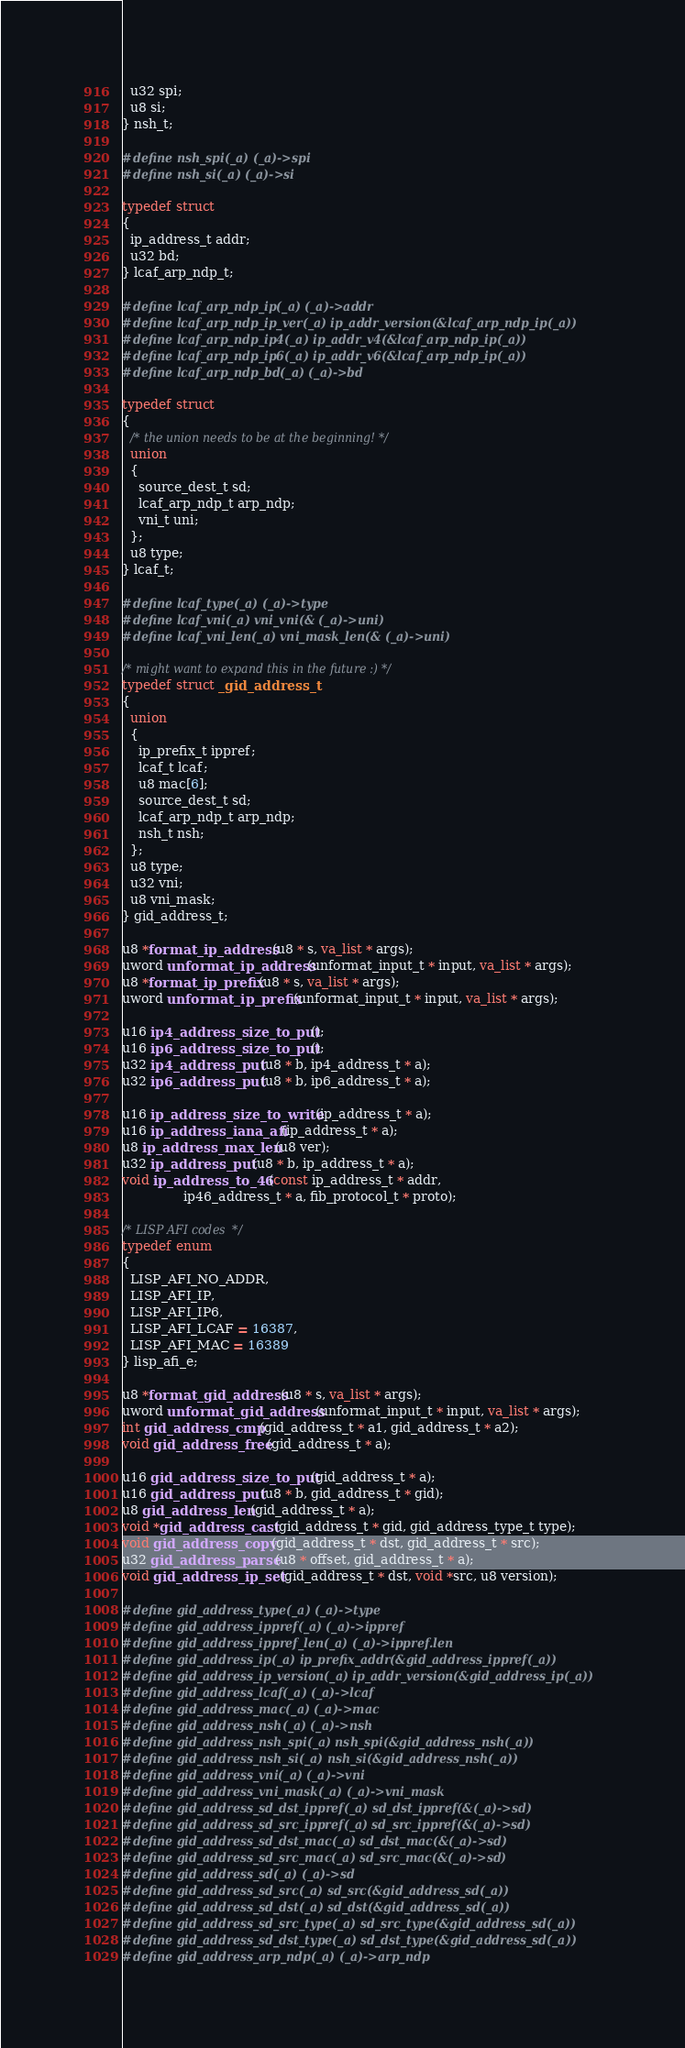<code> <loc_0><loc_0><loc_500><loc_500><_C_>  u32 spi;
  u8 si;
} nsh_t;

#define nsh_spi(_a) (_a)->spi
#define nsh_si(_a) (_a)->si

typedef struct
{
  ip_address_t addr;
  u32 bd;
} lcaf_arp_ndp_t;

#define lcaf_arp_ndp_ip(_a) (_a)->addr
#define lcaf_arp_ndp_ip_ver(_a) ip_addr_version(&lcaf_arp_ndp_ip(_a))
#define lcaf_arp_ndp_ip4(_a) ip_addr_v4(&lcaf_arp_ndp_ip(_a))
#define lcaf_arp_ndp_ip6(_a) ip_addr_v6(&lcaf_arp_ndp_ip(_a))
#define lcaf_arp_ndp_bd(_a) (_a)->bd

typedef struct
{
  /* the union needs to be at the beginning! */
  union
  {
    source_dest_t sd;
    lcaf_arp_ndp_t arp_ndp;
    vni_t uni;
  };
  u8 type;
} lcaf_t;

#define lcaf_type(_a) (_a)->type
#define lcaf_vni(_a) vni_vni(& (_a)->uni)
#define lcaf_vni_len(_a) vni_mask_len(& (_a)->uni)

/* might want to expand this in the future :) */
typedef struct _gid_address_t
{
  union
  {
    ip_prefix_t ippref;
    lcaf_t lcaf;
    u8 mac[6];
    source_dest_t sd;
    lcaf_arp_ndp_t arp_ndp;
    nsh_t nsh;
  };
  u8 type;
  u32 vni;
  u8 vni_mask;
} gid_address_t;

u8 *format_ip_address (u8 * s, va_list * args);
uword unformat_ip_address (unformat_input_t * input, va_list * args);
u8 *format_ip_prefix (u8 * s, va_list * args);
uword unformat_ip_prefix (unformat_input_t * input, va_list * args);

u16 ip4_address_size_to_put ();
u16 ip6_address_size_to_put ();
u32 ip4_address_put (u8 * b, ip4_address_t * a);
u32 ip6_address_put (u8 * b, ip6_address_t * a);

u16 ip_address_size_to_write (ip_address_t * a);
u16 ip_address_iana_afi (ip_address_t * a);
u8 ip_address_max_len (u8 ver);
u32 ip_address_put (u8 * b, ip_address_t * a);
void ip_address_to_46 (const ip_address_t * addr,
		       ip46_address_t * a, fib_protocol_t * proto);

/* LISP AFI codes  */
typedef enum
{
  LISP_AFI_NO_ADDR,
  LISP_AFI_IP,
  LISP_AFI_IP6,
  LISP_AFI_LCAF = 16387,
  LISP_AFI_MAC = 16389
} lisp_afi_e;

u8 *format_gid_address (u8 * s, va_list * args);
uword unformat_gid_address (unformat_input_t * input, va_list * args);
int gid_address_cmp (gid_address_t * a1, gid_address_t * a2);
void gid_address_free (gid_address_t * a);

u16 gid_address_size_to_put (gid_address_t * a);
u16 gid_address_put (u8 * b, gid_address_t * gid);
u8 gid_address_len (gid_address_t * a);
void *gid_address_cast (gid_address_t * gid, gid_address_type_t type);
void gid_address_copy (gid_address_t * dst, gid_address_t * src);
u32 gid_address_parse (u8 * offset, gid_address_t * a);
void gid_address_ip_set (gid_address_t * dst, void *src, u8 version);

#define gid_address_type(_a) (_a)->type
#define gid_address_ippref(_a) (_a)->ippref
#define gid_address_ippref_len(_a) (_a)->ippref.len
#define gid_address_ip(_a) ip_prefix_addr(&gid_address_ippref(_a))
#define gid_address_ip_version(_a) ip_addr_version(&gid_address_ip(_a))
#define gid_address_lcaf(_a) (_a)->lcaf
#define gid_address_mac(_a) (_a)->mac
#define gid_address_nsh(_a) (_a)->nsh
#define gid_address_nsh_spi(_a) nsh_spi(&gid_address_nsh(_a))
#define gid_address_nsh_si(_a) nsh_si(&gid_address_nsh(_a))
#define gid_address_vni(_a) (_a)->vni
#define gid_address_vni_mask(_a) (_a)->vni_mask
#define gid_address_sd_dst_ippref(_a) sd_dst_ippref(&(_a)->sd)
#define gid_address_sd_src_ippref(_a) sd_src_ippref(&(_a)->sd)
#define gid_address_sd_dst_mac(_a) sd_dst_mac(&(_a)->sd)
#define gid_address_sd_src_mac(_a) sd_src_mac(&(_a)->sd)
#define gid_address_sd(_a) (_a)->sd
#define gid_address_sd_src(_a) sd_src(&gid_address_sd(_a))
#define gid_address_sd_dst(_a) sd_dst(&gid_address_sd(_a))
#define gid_address_sd_src_type(_a) sd_src_type(&gid_address_sd(_a))
#define gid_address_sd_dst_type(_a) sd_dst_type(&gid_address_sd(_a))
#define gid_address_arp_ndp(_a) (_a)->arp_ndp</code> 